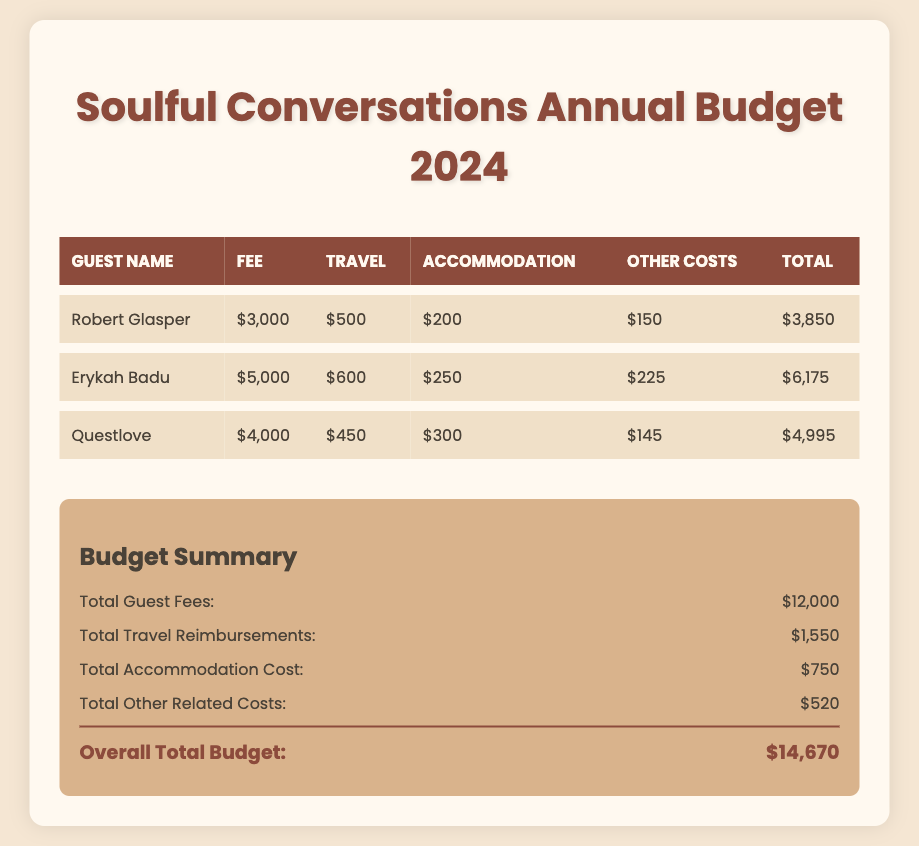What is the guest fee for Robert Glasper? The guest fee for Robert Glasper is stated in the document as $3,000.
Answer: $3,000 What is the total travel reimbursement for all guests? The document lists the total travel reimbursements as $1,550, which is the sum of the travel costs for each guest.
Answer: $1,550 What is the total accommodation cost? The total accommodation cost is provided in the summary section of the document as $750.
Answer: $750 Who has the highest guest fee? The document indicates that Erykah Badu has the highest guest fee at $5,000.
Answer: Erykah Badu What are the total other related costs for the guests? The total other related costs are summarized as $520 in the document.
Answer: $520 How much is the total budget for the year? The overall total budget is calculated in the summary section of the document, which is $14,670.
Answer: $14,670 What is the accommodation cost for Questlove? The accommodation cost for Questlove is stated in the document as $300.
Answer: $300 What is the combined fee for Robert Glasper and Questlove? The sum of the fees for Robert Glasper ($3,000) and Questlove ($4,000) is $7,000.
Answer: $7,000 What is the total number of guests listed in the budget? The budget lists a total of three guests: Robert Glasper, Erykah Badu, and Questlove.
Answer: 3 